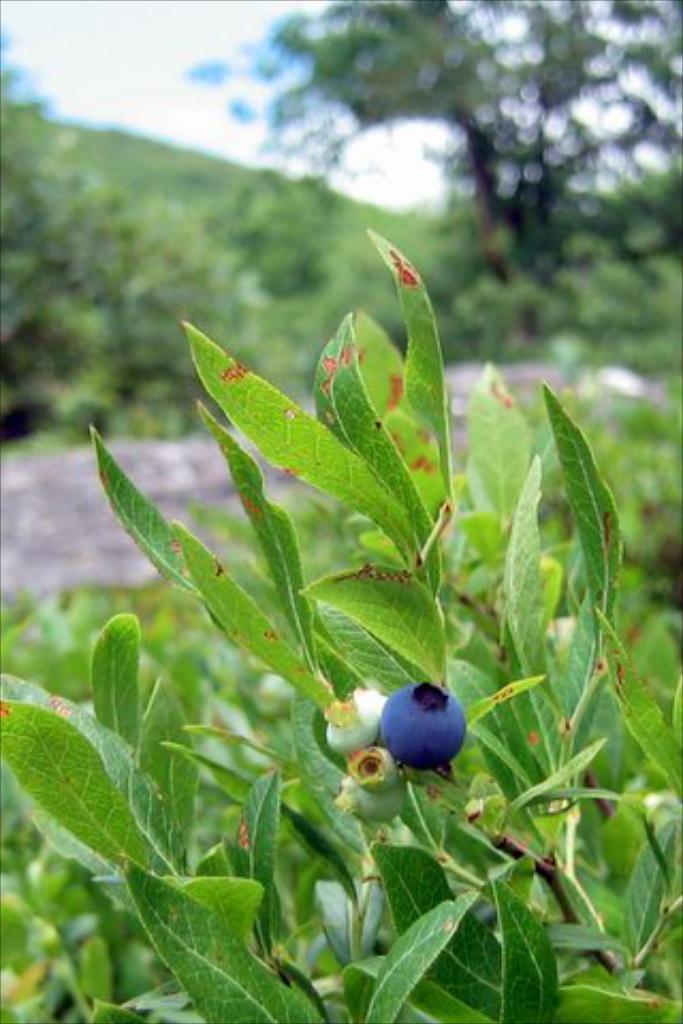What type of living organisms can be seen in the image? Plants can be seen in the image. Can you describe a specific plant in the image? Yes, there is a plant with berries in the image. How would you describe the overall appearance of the image? The background of the image is blurred. How many brothers are visible in the image? There are no brothers present in the image; it features plants and a plant with berries. What type of jar is used to store the plants in the image? There is no jar present in the image; the plants are not contained in any jar. 